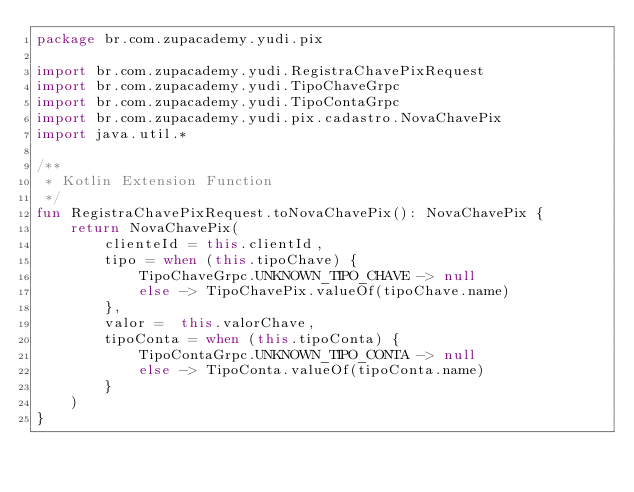Convert code to text. <code><loc_0><loc_0><loc_500><loc_500><_Kotlin_>package br.com.zupacademy.yudi.pix

import br.com.zupacademy.yudi.RegistraChavePixRequest
import br.com.zupacademy.yudi.TipoChaveGrpc
import br.com.zupacademy.yudi.TipoContaGrpc
import br.com.zupacademy.yudi.pix.cadastro.NovaChavePix
import java.util.*

/**
 * Kotlin Extension Function
 */
fun RegistraChavePixRequest.toNovaChavePix(): NovaChavePix {
    return NovaChavePix(
        clienteId = this.clientId,
        tipo = when (this.tipoChave) {
            TipoChaveGrpc.UNKNOWN_TIPO_CHAVE -> null
            else -> TipoChavePix.valueOf(tipoChave.name)
        },
        valor =  this.valorChave,
        tipoConta = when (this.tipoConta) {
            TipoContaGrpc.UNKNOWN_TIPO_CONTA -> null
            else -> TipoConta.valueOf(tipoConta.name)
        }
    )
}</code> 